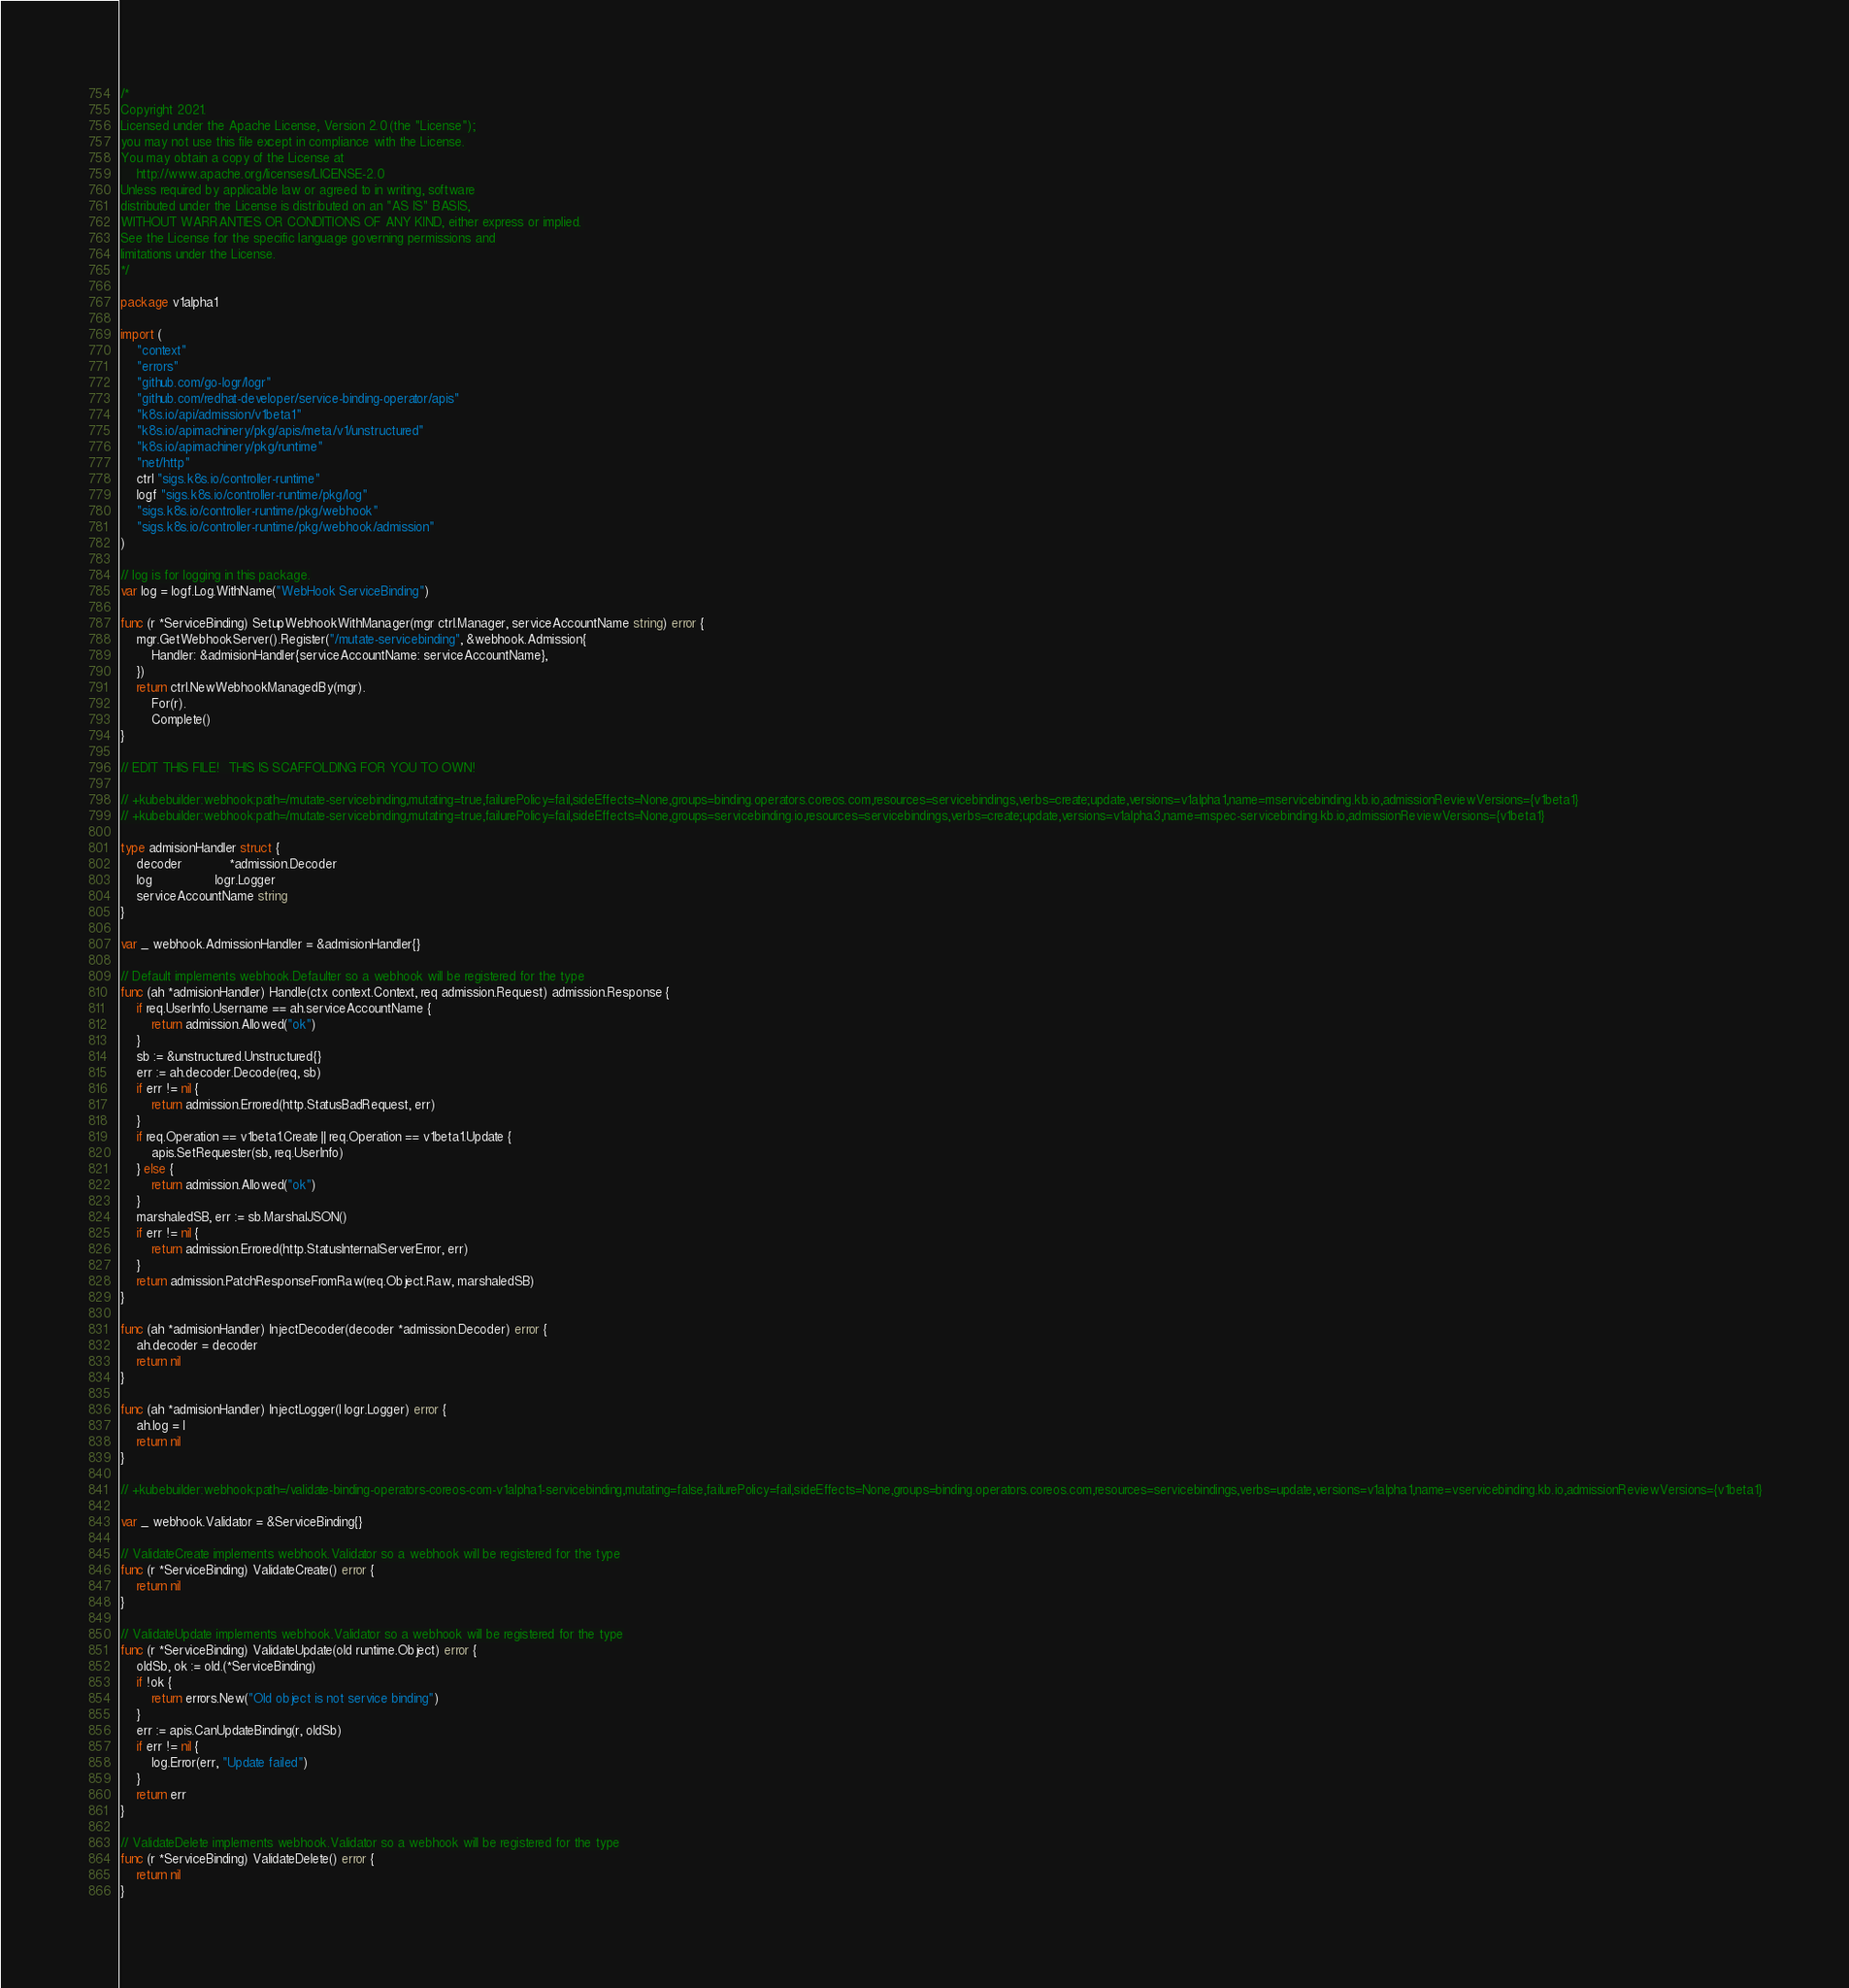<code> <loc_0><loc_0><loc_500><loc_500><_Go_>/*
Copyright 2021.
Licensed under the Apache License, Version 2.0 (the "License");
you may not use this file except in compliance with the License.
You may obtain a copy of the License at
    http://www.apache.org/licenses/LICENSE-2.0
Unless required by applicable law or agreed to in writing, software
distributed under the License is distributed on an "AS IS" BASIS,
WITHOUT WARRANTIES OR CONDITIONS OF ANY KIND, either express or implied.
See the License for the specific language governing permissions and
limitations under the License.
*/

package v1alpha1

import (
	"context"
	"errors"
	"github.com/go-logr/logr"
	"github.com/redhat-developer/service-binding-operator/apis"
	"k8s.io/api/admission/v1beta1"
	"k8s.io/apimachinery/pkg/apis/meta/v1/unstructured"
	"k8s.io/apimachinery/pkg/runtime"
	"net/http"
	ctrl "sigs.k8s.io/controller-runtime"
	logf "sigs.k8s.io/controller-runtime/pkg/log"
	"sigs.k8s.io/controller-runtime/pkg/webhook"
	"sigs.k8s.io/controller-runtime/pkg/webhook/admission"
)

// log is for logging in this package.
var log = logf.Log.WithName("WebHook ServiceBinding")

func (r *ServiceBinding) SetupWebhookWithManager(mgr ctrl.Manager, serviceAccountName string) error {
	mgr.GetWebhookServer().Register("/mutate-servicebinding", &webhook.Admission{
		Handler: &admisionHandler{serviceAccountName: serviceAccountName},
	})
	return ctrl.NewWebhookManagedBy(mgr).
		For(r).
		Complete()
}

// EDIT THIS FILE!  THIS IS SCAFFOLDING FOR YOU TO OWN!

// +kubebuilder:webhook:path=/mutate-servicebinding,mutating=true,failurePolicy=fail,sideEffects=None,groups=binding.operators.coreos.com,resources=servicebindings,verbs=create;update,versions=v1alpha1,name=mservicebinding.kb.io,admissionReviewVersions={v1beta1}
// +kubebuilder:webhook:path=/mutate-servicebinding,mutating=true,failurePolicy=fail,sideEffects=None,groups=servicebinding.io,resources=servicebindings,verbs=create;update,versions=v1alpha3,name=mspec-servicebinding.kb.io,admissionReviewVersions={v1beta1}

type admisionHandler struct {
	decoder            *admission.Decoder
	log                logr.Logger
	serviceAccountName string
}

var _ webhook.AdmissionHandler = &admisionHandler{}

// Default implements webhook.Defaulter so a webhook will be registered for the type
func (ah *admisionHandler) Handle(ctx context.Context, req admission.Request) admission.Response {
	if req.UserInfo.Username == ah.serviceAccountName {
		return admission.Allowed("ok")
	}
	sb := &unstructured.Unstructured{}
	err := ah.decoder.Decode(req, sb)
	if err != nil {
		return admission.Errored(http.StatusBadRequest, err)
	}
	if req.Operation == v1beta1.Create || req.Operation == v1beta1.Update {
		apis.SetRequester(sb, req.UserInfo)
	} else {
		return admission.Allowed("ok")
	}
	marshaledSB, err := sb.MarshalJSON()
	if err != nil {
		return admission.Errored(http.StatusInternalServerError, err)
	}
	return admission.PatchResponseFromRaw(req.Object.Raw, marshaledSB)
}

func (ah *admisionHandler) InjectDecoder(decoder *admission.Decoder) error {
	ah.decoder = decoder
	return nil
}

func (ah *admisionHandler) InjectLogger(l logr.Logger) error {
	ah.log = l
	return nil
}

// +kubebuilder:webhook:path=/validate-binding-operators-coreos-com-v1alpha1-servicebinding,mutating=false,failurePolicy=fail,sideEffects=None,groups=binding.operators.coreos.com,resources=servicebindings,verbs=update,versions=v1alpha1,name=vservicebinding.kb.io,admissionReviewVersions={v1beta1}

var _ webhook.Validator = &ServiceBinding{}

// ValidateCreate implements webhook.Validator so a webhook will be registered for the type
func (r *ServiceBinding) ValidateCreate() error {
	return nil
}

// ValidateUpdate implements webhook.Validator so a webhook will be registered for the type
func (r *ServiceBinding) ValidateUpdate(old runtime.Object) error {
	oldSb, ok := old.(*ServiceBinding)
	if !ok {
		return errors.New("Old object is not service binding")
	}
	err := apis.CanUpdateBinding(r, oldSb)
	if err != nil {
		log.Error(err, "Update failed")
	}
	return err
}

// ValidateDelete implements webhook.Validator so a webhook will be registered for the type
func (r *ServiceBinding) ValidateDelete() error {
	return nil
}
</code> 